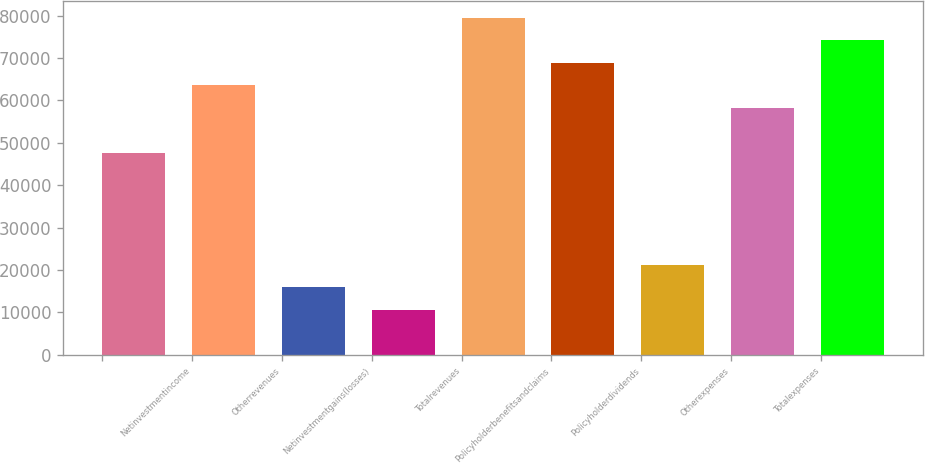Convert chart to OTSL. <chart><loc_0><loc_0><loc_500><loc_500><bar_chart><ecel><fcel>Netinvestmentincome<fcel>Otherrevenues<fcel>Netinvestmentgains(losses)<fcel>Totalrevenues<fcel>Policyholderbenefitsandclaims<fcel>Policyholderdividends<fcel>Otherexpenses<fcel>Totalexpenses<nl><fcel>47710<fcel>63601<fcel>15928<fcel>10631<fcel>79492<fcel>68898<fcel>21225<fcel>58304<fcel>74195<nl></chart> 